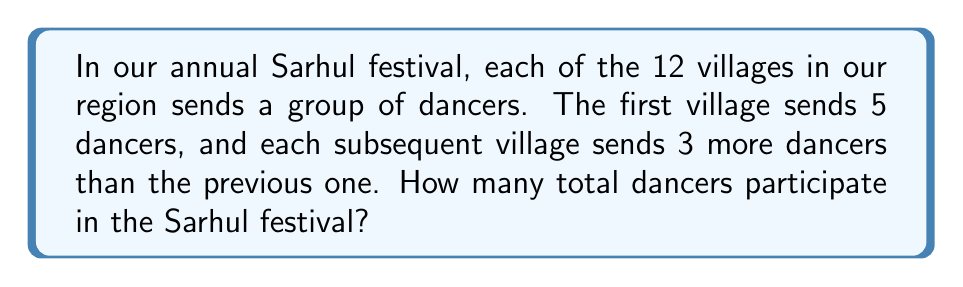Give your solution to this math problem. To solve this problem, we need to recognize that this is an arithmetic sequence with 12 terms. Let's break it down step-by-step:

1. Identify the sequence:
   - First term (a₁) = 5
   - Common difference (d) = 3
   - Number of terms (n) = 12

2. For an arithmetic sequence, we can use the formula for the sum:
   $$ S_n = \frac{n}{2}(a_1 + a_n) $$
   where $a_n$ is the last term.

3. To find $a_n$, we use the arithmetic sequence formula:
   $$ a_n = a_1 + (n-1)d $$
   $$ a_{12} = 5 + (12-1)3 = 5 + 33 = 38 $$

4. Now we can apply the sum formula:
   $$ S_{12} = \frac{12}{2}(5 + 38) = 6(43) = 258 $$

Therefore, the total number of dancers participating in the Sarhul festival is 258.
Answer: 258 dancers 